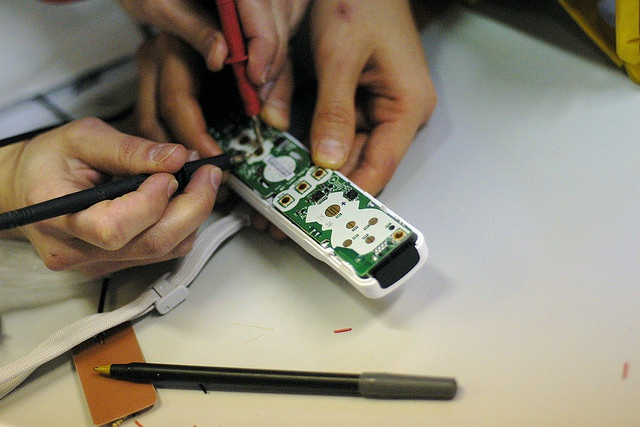Describe the objects in this image and their specific colors. I can see people in gray, tan, black, and maroon tones, people in gray, black, and maroon tones, and remote in gray, black, beige, darkgray, and darkgreen tones in this image. 